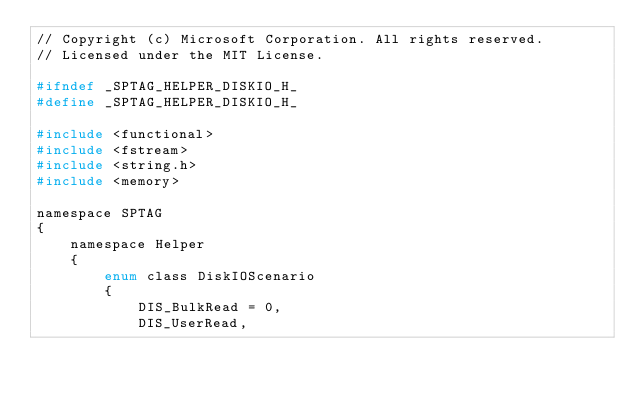Convert code to text. <code><loc_0><loc_0><loc_500><loc_500><_C_>// Copyright (c) Microsoft Corporation. All rights reserved.
// Licensed under the MIT License.

#ifndef _SPTAG_HELPER_DISKIO_H_
#define _SPTAG_HELPER_DISKIO_H_

#include <functional>
#include <fstream>
#include <string.h>
#include <memory>

namespace SPTAG
{
    namespace Helper
    {
        enum class DiskIOScenario
        {
            DIS_BulkRead = 0,
            DIS_UserRead,</code> 